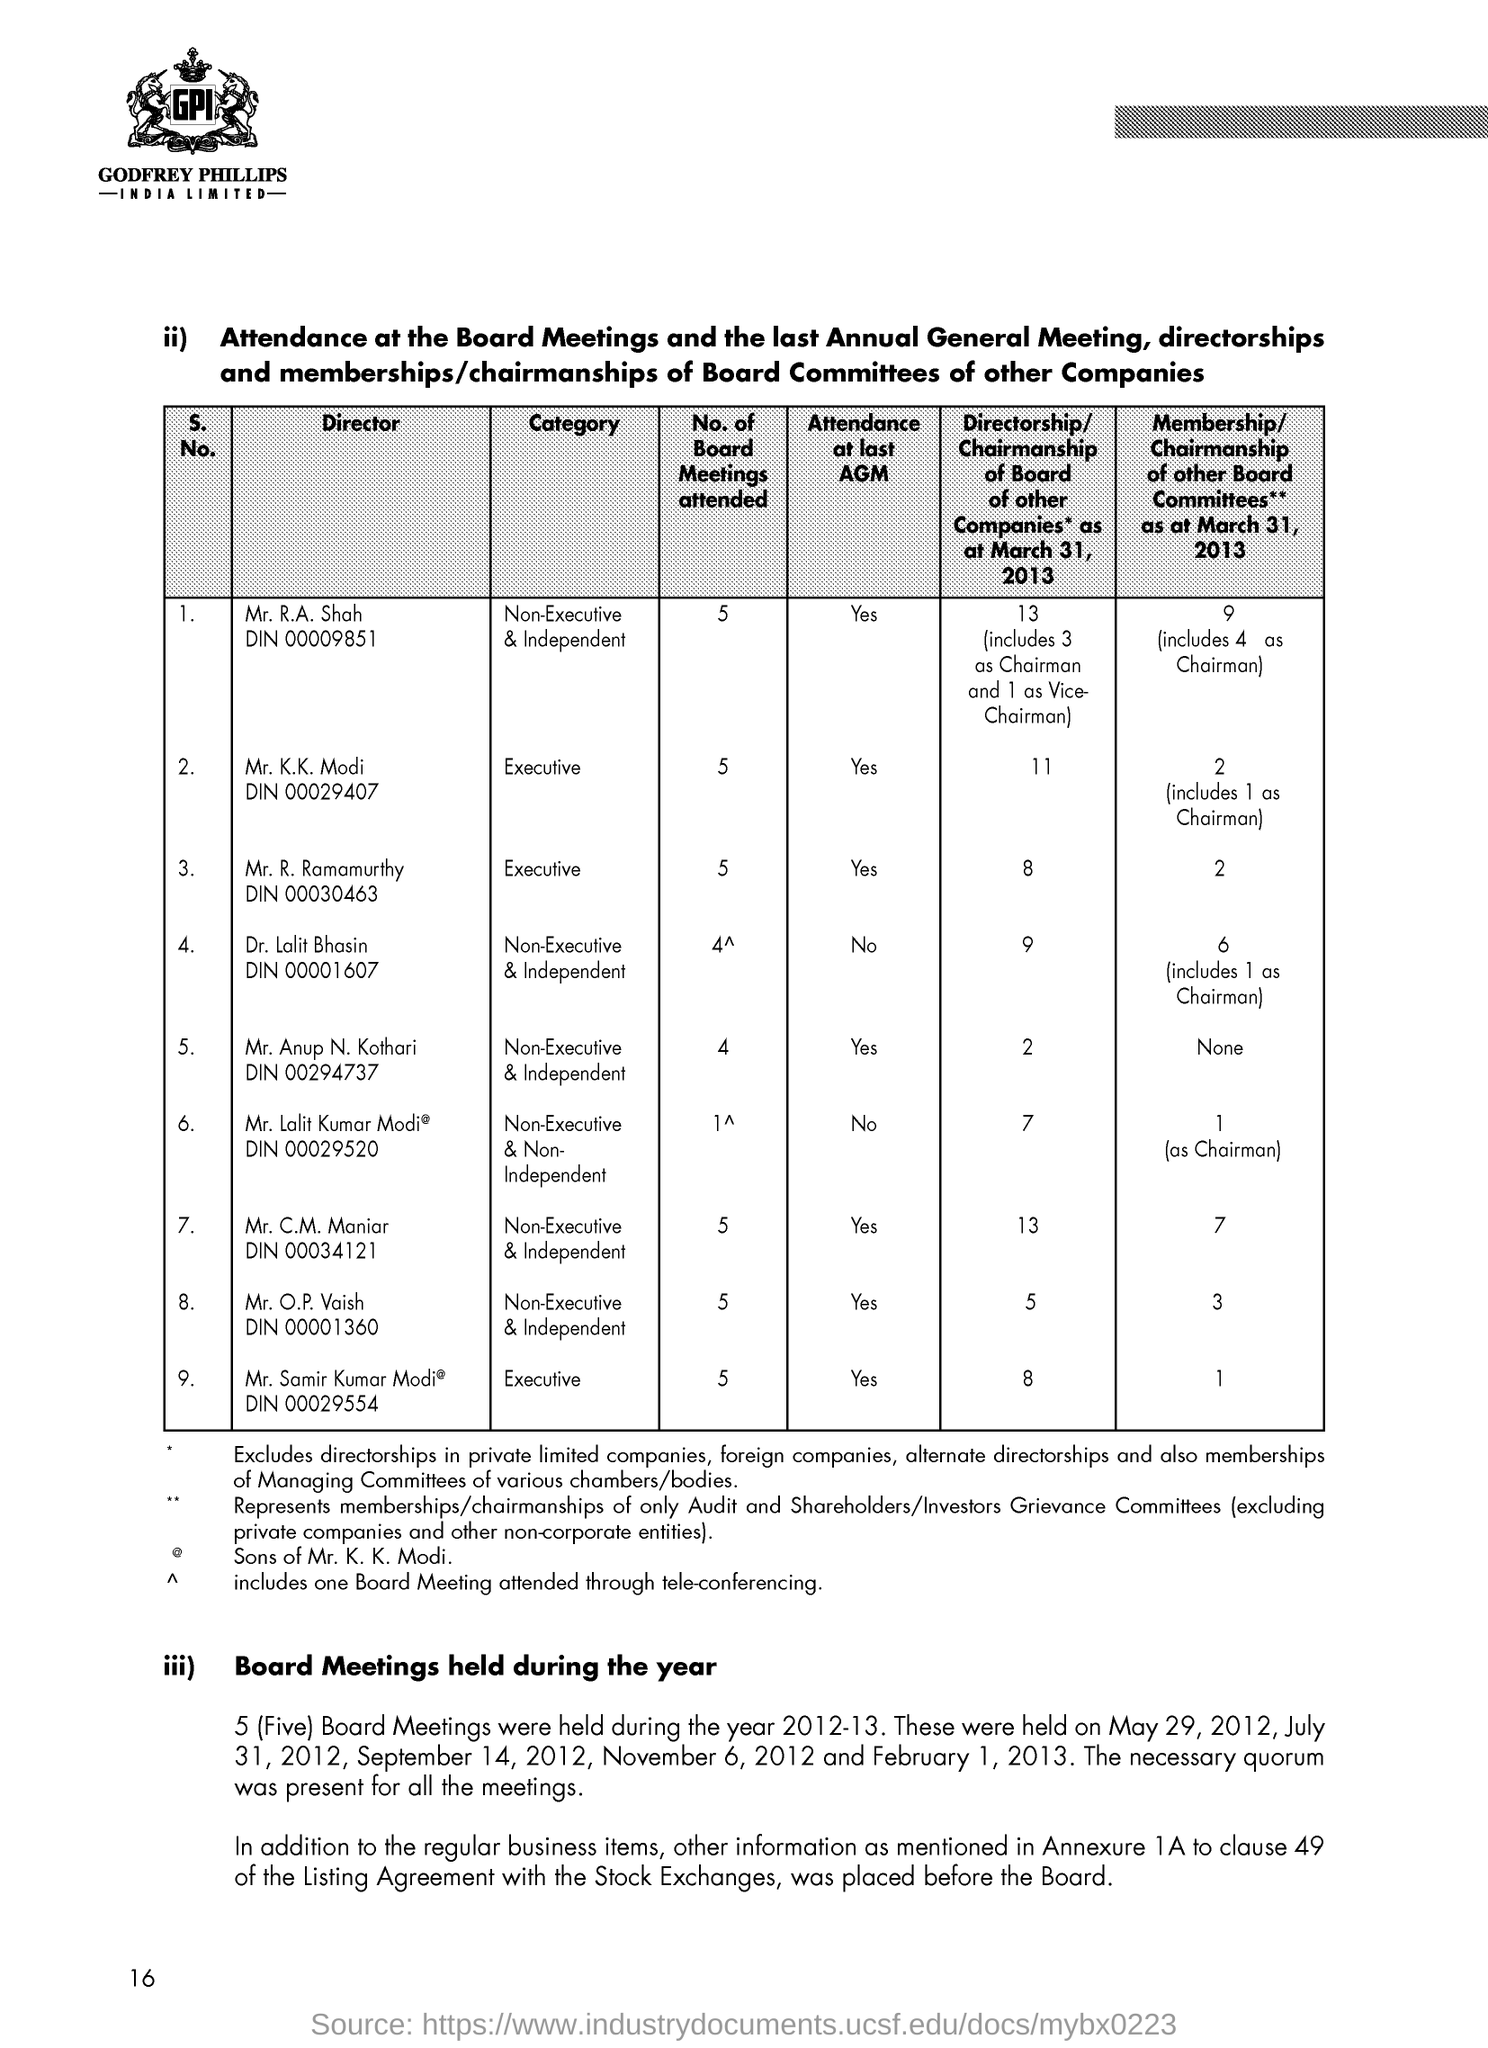Outline some significant characteristics in this image. The page number is 16. Mr. R. A. Shah has attended 5 meetings of the board. Mr. K. K. Modi has attended 5 board meetings. Mr. Anup N. Kothari attended a total of 4 board meetings. Mr. Lalit Kumar Modi attended 1 board meeting. 